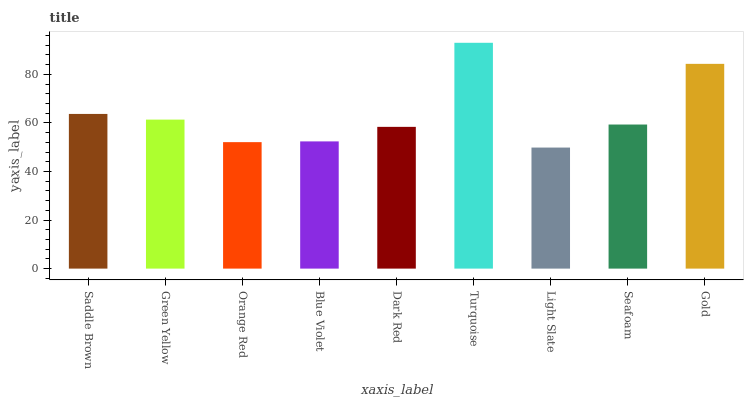Is Light Slate the minimum?
Answer yes or no. Yes. Is Turquoise the maximum?
Answer yes or no. Yes. Is Green Yellow the minimum?
Answer yes or no. No. Is Green Yellow the maximum?
Answer yes or no. No. Is Saddle Brown greater than Green Yellow?
Answer yes or no. Yes. Is Green Yellow less than Saddle Brown?
Answer yes or no. Yes. Is Green Yellow greater than Saddle Brown?
Answer yes or no. No. Is Saddle Brown less than Green Yellow?
Answer yes or no. No. Is Seafoam the high median?
Answer yes or no. Yes. Is Seafoam the low median?
Answer yes or no. Yes. Is Turquoise the high median?
Answer yes or no. No. Is Blue Violet the low median?
Answer yes or no. No. 